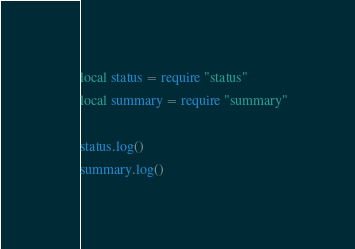<code> <loc_0><loc_0><loc_500><loc_500><_Lua_>local status = require "status"
local summary = require "summary"

status.log()
summary.log()
</code> 